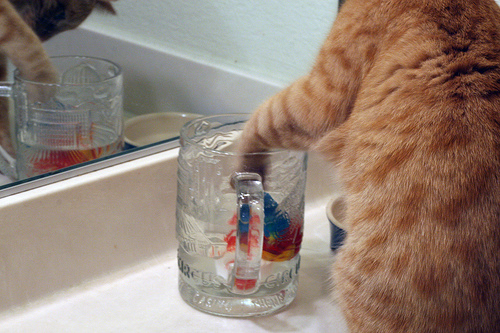<image>
Can you confirm if the cat is on the glass? No. The cat is not positioned on the glass. They may be near each other, but the cat is not supported by or resting on top of the glass. Is the stein under the cat? Yes. The stein is positioned underneath the cat, with the cat above it in the vertical space. Is there a glass behind the cat paw? No. The glass is not behind the cat paw. From this viewpoint, the glass appears to be positioned elsewhere in the scene. Is the cat in front of the glass? Yes. The cat is positioned in front of the glass, appearing closer to the camera viewpoint. Is there a cat above the cup? Yes. The cat is positioned above the cup in the vertical space, higher up in the scene. 